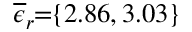<formula> <loc_0><loc_0><loc_500><loc_500>\, \overline { \epsilon } _ { r } \, = \, \{ 2 . 8 6 , 3 . 0 3 \} \,</formula> 